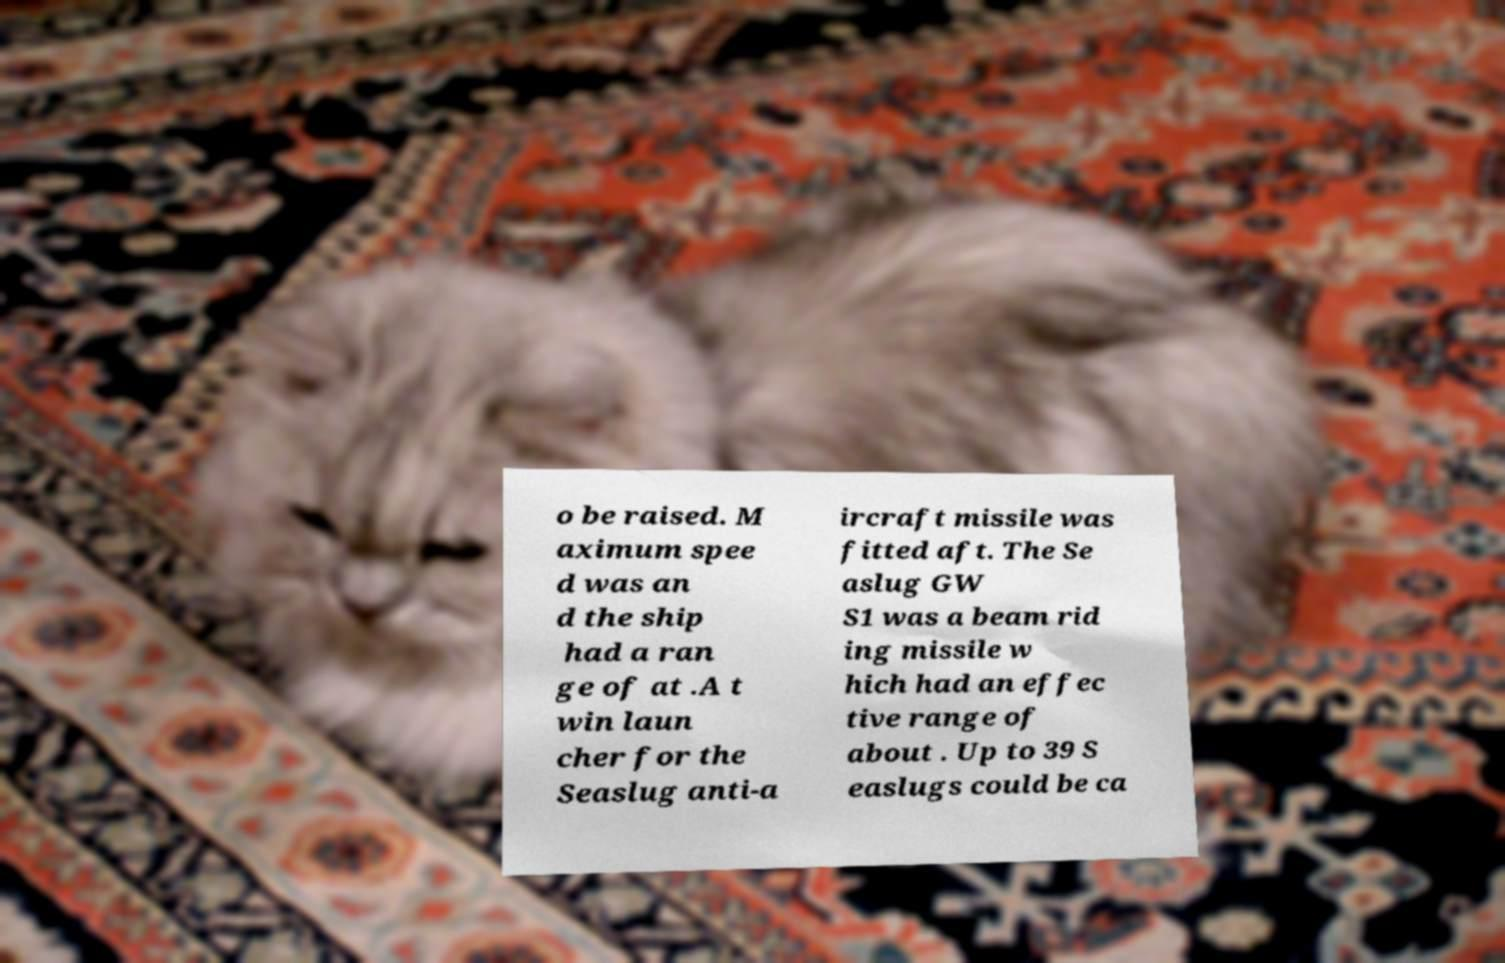For documentation purposes, I need the text within this image transcribed. Could you provide that? o be raised. M aximum spee d was an d the ship had a ran ge of at .A t win laun cher for the Seaslug anti-a ircraft missile was fitted aft. The Se aslug GW S1 was a beam rid ing missile w hich had an effec tive range of about . Up to 39 S easlugs could be ca 